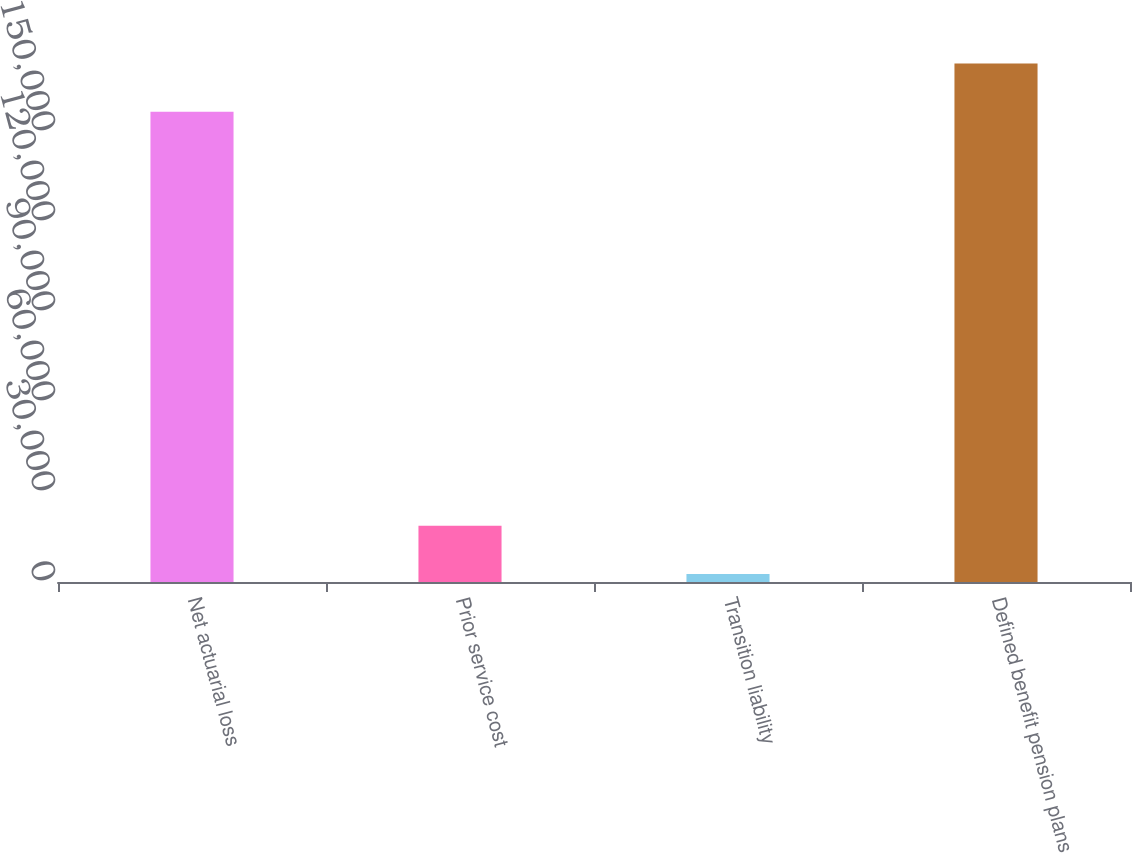<chart> <loc_0><loc_0><loc_500><loc_500><bar_chart><fcel>Net actuarial loss<fcel>Prior service cost<fcel>Transition liability<fcel>Defined benefit pension plans<nl><fcel>156762<fcel>18778.5<fcel>2690<fcel>172850<nl></chart> 